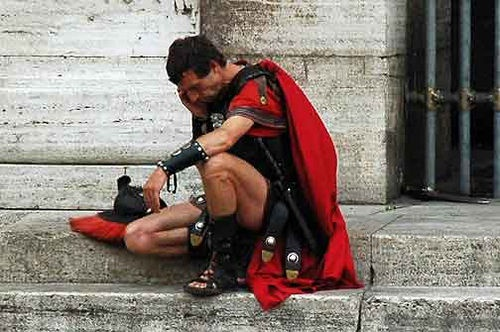Describe the objects in this image and their specific colors. I can see people in lightgray, black, maroon, and brown tones in this image. 